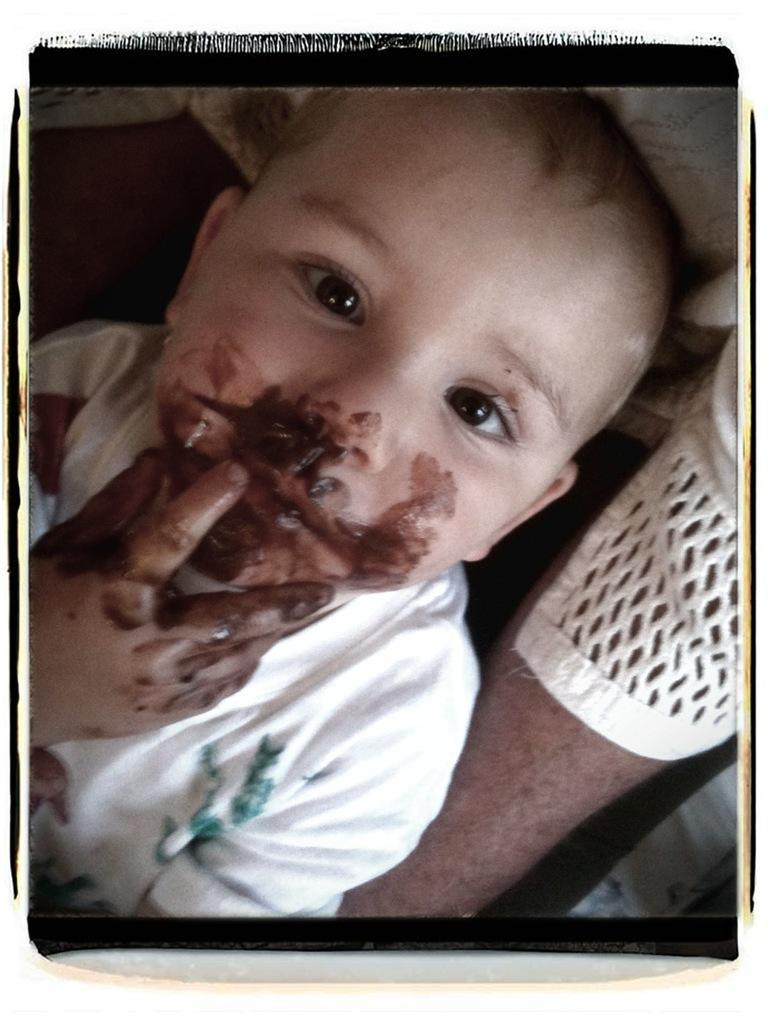How would you summarize this image in a sentence or two? In this picture we can see a person hand and boy. On his face and hand there is a chocolate cream.  